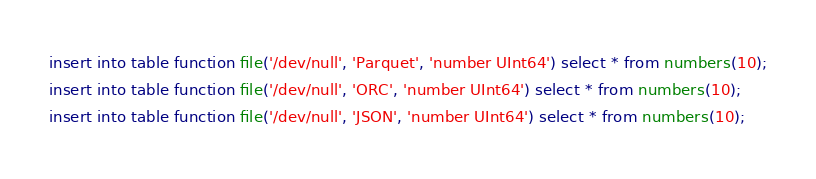<code> <loc_0><loc_0><loc_500><loc_500><_SQL_>
insert into table function file('/dev/null', 'Parquet', 'number UInt64') select * from numbers(10);
insert into table function file('/dev/null', 'ORC', 'number UInt64') select * from numbers(10);
insert into table function file('/dev/null', 'JSON', 'number UInt64') select * from numbers(10);

</code> 